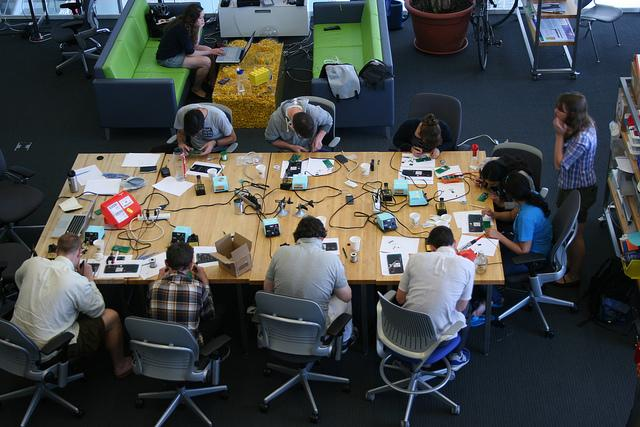What would soon stop here if there were a power outage?

Choices:
A) nothing
B) all work
C) parties
D) silence all work 